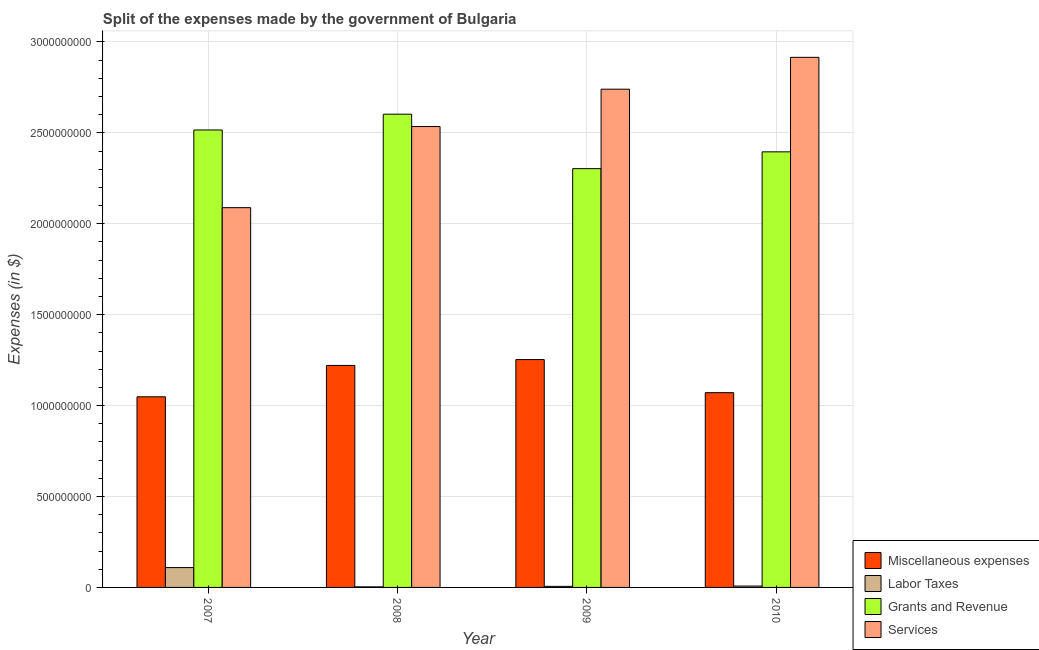How many different coloured bars are there?
Offer a very short reply. 4. How many groups of bars are there?
Ensure brevity in your answer.  4. How many bars are there on the 1st tick from the right?
Your response must be concise. 4. What is the amount spent on labor taxes in 2009?
Provide a succinct answer. 5.93e+06. Across all years, what is the maximum amount spent on services?
Keep it short and to the point. 2.92e+09. Across all years, what is the minimum amount spent on labor taxes?
Keep it short and to the point. 3.12e+06. In which year was the amount spent on labor taxes minimum?
Make the answer very short. 2008. What is the total amount spent on services in the graph?
Give a very brief answer. 1.03e+1. What is the difference between the amount spent on labor taxes in 2008 and that in 2009?
Keep it short and to the point. -2.81e+06. What is the difference between the amount spent on miscellaneous expenses in 2009 and the amount spent on services in 2007?
Your answer should be very brief. 2.05e+08. What is the average amount spent on grants and revenue per year?
Your answer should be compact. 2.45e+09. In the year 2008, what is the difference between the amount spent on services and amount spent on labor taxes?
Offer a terse response. 0. What is the ratio of the amount spent on miscellaneous expenses in 2007 to that in 2010?
Make the answer very short. 0.98. Is the amount spent on grants and revenue in 2008 less than that in 2009?
Offer a terse response. No. What is the difference between the highest and the second highest amount spent on miscellaneous expenses?
Give a very brief answer. 3.22e+07. What is the difference between the highest and the lowest amount spent on miscellaneous expenses?
Ensure brevity in your answer.  2.05e+08. In how many years, is the amount spent on services greater than the average amount spent on services taken over all years?
Your answer should be very brief. 2. Is the sum of the amount spent on labor taxes in 2007 and 2009 greater than the maximum amount spent on grants and revenue across all years?
Give a very brief answer. Yes. What does the 4th bar from the left in 2007 represents?
Your answer should be very brief. Services. What does the 2nd bar from the right in 2010 represents?
Offer a very short reply. Grants and Revenue. Is it the case that in every year, the sum of the amount spent on miscellaneous expenses and amount spent on labor taxes is greater than the amount spent on grants and revenue?
Ensure brevity in your answer.  No. How many bars are there?
Keep it short and to the point. 16. What is the difference between two consecutive major ticks on the Y-axis?
Ensure brevity in your answer.  5.00e+08. Are the values on the major ticks of Y-axis written in scientific E-notation?
Ensure brevity in your answer.  No. Does the graph contain grids?
Provide a short and direct response. Yes. What is the title of the graph?
Provide a short and direct response. Split of the expenses made by the government of Bulgaria. What is the label or title of the Y-axis?
Offer a very short reply. Expenses (in $). What is the Expenses (in $) in Miscellaneous expenses in 2007?
Make the answer very short. 1.05e+09. What is the Expenses (in $) of Labor Taxes in 2007?
Offer a terse response. 1.09e+08. What is the Expenses (in $) of Grants and Revenue in 2007?
Give a very brief answer. 2.52e+09. What is the Expenses (in $) of Services in 2007?
Your answer should be very brief. 2.09e+09. What is the Expenses (in $) of Miscellaneous expenses in 2008?
Provide a short and direct response. 1.22e+09. What is the Expenses (in $) of Labor Taxes in 2008?
Ensure brevity in your answer.  3.12e+06. What is the Expenses (in $) of Grants and Revenue in 2008?
Give a very brief answer. 2.60e+09. What is the Expenses (in $) of Services in 2008?
Give a very brief answer. 2.53e+09. What is the Expenses (in $) of Miscellaneous expenses in 2009?
Offer a very short reply. 1.25e+09. What is the Expenses (in $) in Labor Taxes in 2009?
Offer a terse response. 5.93e+06. What is the Expenses (in $) in Grants and Revenue in 2009?
Give a very brief answer. 2.30e+09. What is the Expenses (in $) in Services in 2009?
Provide a succinct answer. 2.74e+09. What is the Expenses (in $) of Miscellaneous expenses in 2010?
Give a very brief answer. 1.07e+09. What is the Expenses (in $) of Labor Taxes in 2010?
Give a very brief answer. 7.65e+06. What is the Expenses (in $) of Grants and Revenue in 2010?
Ensure brevity in your answer.  2.40e+09. What is the Expenses (in $) of Services in 2010?
Offer a very short reply. 2.92e+09. Across all years, what is the maximum Expenses (in $) of Miscellaneous expenses?
Provide a short and direct response. 1.25e+09. Across all years, what is the maximum Expenses (in $) of Labor Taxes?
Offer a terse response. 1.09e+08. Across all years, what is the maximum Expenses (in $) in Grants and Revenue?
Your answer should be very brief. 2.60e+09. Across all years, what is the maximum Expenses (in $) of Services?
Ensure brevity in your answer.  2.92e+09. Across all years, what is the minimum Expenses (in $) in Miscellaneous expenses?
Ensure brevity in your answer.  1.05e+09. Across all years, what is the minimum Expenses (in $) in Labor Taxes?
Your answer should be very brief. 3.12e+06. Across all years, what is the minimum Expenses (in $) in Grants and Revenue?
Your response must be concise. 2.30e+09. Across all years, what is the minimum Expenses (in $) in Services?
Offer a terse response. 2.09e+09. What is the total Expenses (in $) in Miscellaneous expenses in the graph?
Provide a short and direct response. 4.59e+09. What is the total Expenses (in $) of Labor Taxes in the graph?
Provide a succinct answer. 1.26e+08. What is the total Expenses (in $) of Grants and Revenue in the graph?
Your answer should be compact. 9.82e+09. What is the total Expenses (in $) of Services in the graph?
Your answer should be compact. 1.03e+1. What is the difference between the Expenses (in $) of Miscellaneous expenses in 2007 and that in 2008?
Your response must be concise. -1.72e+08. What is the difference between the Expenses (in $) in Labor Taxes in 2007 and that in 2008?
Provide a short and direct response. 1.06e+08. What is the difference between the Expenses (in $) of Grants and Revenue in 2007 and that in 2008?
Give a very brief answer. -8.67e+07. What is the difference between the Expenses (in $) of Services in 2007 and that in 2008?
Offer a terse response. -4.46e+08. What is the difference between the Expenses (in $) in Miscellaneous expenses in 2007 and that in 2009?
Provide a succinct answer. -2.05e+08. What is the difference between the Expenses (in $) in Labor Taxes in 2007 and that in 2009?
Provide a short and direct response. 1.03e+08. What is the difference between the Expenses (in $) of Grants and Revenue in 2007 and that in 2009?
Give a very brief answer. 2.13e+08. What is the difference between the Expenses (in $) of Services in 2007 and that in 2009?
Your answer should be very brief. -6.52e+08. What is the difference between the Expenses (in $) in Miscellaneous expenses in 2007 and that in 2010?
Provide a succinct answer. -2.27e+07. What is the difference between the Expenses (in $) in Labor Taxes in 2007 and that in 2010?
Provide a succinct answer. 1.01e+08. What is the difference between the Expenses (in $) of Grants and Revenue in 2007 and that in 2010?
Make the answer very short. 1.20e+08. What is the difference between the Expenses (in $) of Services in 2007 and that in 2010?
Make the answer very short. -8.27e+08. What is the difference between the Expenses (in $) in Miscellaneous expenses in 2008 and that in 2009?
Your answer should be very brief. -3.22e+07. What is the difference between the Expenses (in $) of Labor Taxes in 2008 and that in 2009?
Ensure brevity in your answer.  -2.81e+06. What is the difference between the Expenses (in $) of Grants and Revenue in 2008 and that in 2009?
Provide a succinct answer. 2.99e+08. What is the difference between the Expenses (in $) in Services in 2008 and that in 2009?
Provide a short and direct response. -2.05e+08. What is the difference between the Expenses (in $) in Miscellaneous expenses in 2008 and that in 2010?
Ensure brevity in your answer.  1.50e+08. What is the difference between the Expenses (in $) in Labor Taxes in 2008 and that in 2010?
Your answer should be compact. -4.53e+06. What is the difference between the Expenses (in $) of Grants and Revenue in 2008 and that in 2010?
Make the answer very short. 2.07e+08. What is the difference between the Expenses (in $) of Services in 2008 and that in 2010?
Offer a terse response. -3.81e+08. What is the difference between the Expenses (in $) of Miscellaneous expenses in 2009 and that in 2010?
Your answer should be compact. 1.82e+08. What is the difference between the Expenses (in $) in Labor Taxes in 2009 and that in 2010?
Your answer should be very brief. -1.72e+06. What is the difference between the Expenses (in $) of Grants and Revenue in 2009 and that in 2010?
Your answer should be very brief. -9.24e+07. What is the difference between the Expenses (in $) of Services in 2009 and that in 2010?
Your answer should be compact. -1.75e+08. What is the difference between the Expenses (in $) of Miscellaneous expenses in 2007 and the Expenses (in $) of Labor Taxes in 2008?
Offer a very short reply. 1.05e+09. What is the difference between the Expenses (in $) in Miscellaneous expenses in 2007 and the Expenses (in $) in Grants and Revenue in 2008?
Provide a short and direct response. -1.55e+09. What is the difference between the Expenses (in $) of Miscellaneous expenses in 2007 and the Expenses (in $) of Services in 2008?
Make the answer very short. -1.49e+09. What is the difference between the Expenses (in $) in Labor Taxes in 2007 and the Expenses (in $) in Grants and Revenue in 2008?
Your answer should be very brief. -2.49e+09. What is the difference between the Expenses (in $) in Labor Taxes in 2007 and the Expenses (in $) in Services in 2008?
Offer a terse response. -2.43e+09. What is the difference between the Expenses (in $) of Grants and Revenue in 2007 and the Expenses (in $) of Services in 2008?
Keep it short and to the point. -1.88e+07. What is the difference between the Expenses (in $) of Miscellaneous expenses in 2007 and the Expenses (in $) of Labor Taxes in 2009?
Provide a short and direct response. 1.04e+09. What is the difference between the Expenses (in $) in Miscellaneous expenses in 2007 and the Expenses (in $) in Grants and Revenue in 2009?
Give a very brief answer. -1.25e+09. What is the difference between the Expenses (in $) of Miscellaneous expenses in 2007 and the Expenses (in $) of Services in 2009?
Make the answer very short. -1.69e+09. What is the difference between the Expenses (in $) of Labor Taxes in 2007 and the Expenses (in $) of Grants and Revenue in 2009?
Offer a very short reply. -2.19e+09. What is the difference between the Expenses (in $) in Labor Taxes in 2007 and the Expenses (in $) in Services in 2009?
Offer a terse response. -2.63e+09. What is the difference between the Expenses (in $) of Grants and Revenue in 2007 and the Expenses (in $) of Services in 2009?
Make the answer very short. -2.24e+08. What is the difference between the Expenses (in $) in Miscellaneous expenses in 2007 and the Expenses (in $) in Labor Taxes in 2010?
Provide a succinct answer. 1.04e+09. What is the difference between the Expenses (in $) of Miscellaneous expenses in 2007 and the Expenses (in $) of Grants and Revenue in 2010?
Your answer should be very brief. -1.35e+09. What is the difference between the Expenses (in $) of Miscellaneous expenses in 2007 and the Expenses (in $) of Services in 2010?
Your response must be concise. -1.87e+09. What is the difference between the Expenses (in $) of Labor Taxes in 2007 and the Expenses (in $) of Grants and Revenue in 2010?
Make the answer very short. -2.29e+09. What is the difference between the Expenses (in $) of Labor Taxes in 2007 and the Expenses (in $) of Services in 2010?
Your response must be concise. -2.81e+09. What is the difference between the Expenses (in $) of Grants and Revenue in 2007 and the Expenses (in $) of Services in 2010?
Keep it short and to the point. -3.99e+08. What is the difference between the Expenses (in $) of Miscellaneous expenses in 2008 and the Expenses (in $) of Labor Taxes in 2009?
Provide a succinct answer. 1.21e+09. What is the difference between the Expenses (in $) in Miscellaneous expenses in 2008 and the Expenses (in $) in Grants and Revenue in 2009?
Make the answer very short. -1.08e+09. What is the difference between the Expenses (in $) in Miscellaneous expenses in 2008 and the Expenses (in $) in Services in 2009?
Ensure brevity in your answer.  -1.52e+09. What is the difference between the Expenses (in $) in Labor Taxes in 2008 and the Expenses (in $) in Grants and Revenue in 2009?
Provide a succinct answer. -2.30e+09. What is the difference between the Expenses (in $) in Labor Taxes in 2008 and the Expenses (in $) in Services in 2009?
Give a very brief answer. -2.74e+09. What is the difference between the Expenses (in $) in Grants and Revenue in 2008 and the Expenses (in $) in Services in 2009?
Offer a terse response. -1.37e+08. What is the difference between the Expenses (in $) in Miscellaneous expenses in 2008 and the Expenses (in $) in Labor Taxes in 2010?
Offer a terse response. 1.21e+09. What is the difference between the Expenses (in $) in Miscellaneous expenses in 2008 and the Expenses (in $) in Grants and Revenue in 2010?
Offer a very short reply. -1.17e+09. What is the difference between the Expenses (in $) in Miscellaneous expenses in 2008 and the Expenses (in $) in Services in 2010?
Ensure brevity in your answer.  -1.69e+09. What is the difference between the Expenses (in $) in Labor Taxes in 2008 and the Expenses (in $) in Grants and Revenue in 2010?
Offer a very short reply. -2.39e+09. What is the difference between the Expenses (in $) of Labor Taxes in 2008 and the Expenses (in $) of Services in 2010?
Ensure brevity in your answer.  -2.91e+09. What is the difference between the Expenses (in $) in Grants and Revenue in 2008 and the Expenses (in $) in Services in 2010?
Your answer should be compact. -3.13e+08. What is the difference between the Expenses (in $) of Miscellaneous expenses in 2009 and the Expenses (in $) of Labor Taxes in 2010?
Your response must be concise. 1.25e+09. What is the difference between the Expenses (in $) of Miscellaneous expenses in 2009 and the Expenses (in $) of Grants and Revenue in 2010?
Provide a short and direct response. -1.14e+09. What is the difference between the Expenses (in $) in Miscellaneous expenses in 2009 and the Expenses (in $) in Services in 2010?
Offer a very short reply. -1.66e+09. What is the difference between the Expenses (in $) of Labor Taxes in 2009 and the Expenses (in $) of Grants and Revenue in 2010?
Make the answer very short. -2.39e+09. What is the difference between the Expenses (in $) in Labor Taxes in 2009 and the Expenses (in $) in Services in 2010?
Your answer should be very brief. -2.91e+09. What is the difference between the Expenses (in $) of Grants and Revenue in 2009 and the Expenses (in $) of Services in 2010?
Give a very brief answer. -6.12e+08. What is the average Expenses (in $) in Miscellaneous expenses per year?
Ensure brevity in your answer.  1.15e+09. What is the average Expenses (in $) in Labor Taxes per year?
Give a very brief answer. 3.14e+07. What is the average Expenses (in $) of Grants and Revenue per year?
Provide a succinct answer. 2.45e+09. What is the average Expenses (in $) in Services per year?
Ensure brevity in your answer.  2.57e+09. In the year 2007, what is the difference between the Expenses (in $) in Miscellaneous expenses and Expenses (in $) in Labor Taxes?
Offer a very short reply. 9.39e+08. In the year 2007, what is the difference between the Expenses (in $) in Miscellaneous expenses and Expenses (in $) in Grants and Revenue?
Your answer should be very brief. -1.47e+09. In the year 2007, what is the difference between the Expenses (in $) of Miscellaneous expenses and Expenses (in $) of Services?
Offer a terse response. -1.04e+09. In the year 2007, what is the difference between the Expenses (in $) of Labor Taxes and Expenses (in $) of Grants and Revenue?
Give a very brief answer. -2.41e+09. In the year 2007, what is the difference between the Expenses (in $) in Labor Taxes and Expenses (in $) in Services?
Your answer should be compact. -1.98e+09. In the year 2007, what is the difference between the Expenses (in $) in Grants and Revenue and Expenses (in $) in Services?
Provide a succinct answer. 4.27e+08. In the year 2008, what is the difference between the Expenses (in $) of Miscellaneous expenses and Expenses (in $) of Labor Taxes?
Make the answer very short. 1.22e+09. In the year 2008, what is the difference between the Expenses (in $) of Miscellaneous expenses and Expenses (in $) of Grants and Revenue?
Your response must be concise. -1.38e+09. In the year 2008, what is the difference between the Expenses (in $) in Miscellaneous expenses and Expenses (in $) in Services?
Your answer should be compact. -1.31e+09. In the year 2008, what is the difference between the Expenses (in $) in Labor Taxes and Expenses (in $) in Grants and Revenue?
Your response must be concise. -2.60e+09. In the year 2008, what is the difference between the Expenses (in $) of Labor Taxes and Expenses (in $) of Services?
Ensure brevity in your answer.  -2.53e+09. In the year 2008, what is the difference between the Expenses (in $) of Grants and Revenue and Expenses (in $) of Services?
Your answer should be very brief. 6.79e+07. In the year 2009, what is the difference between the Expenses (in $) of Miscellaneous expenses and Expenses (in $) of Labor Taxes?
Your response must be concise. 1.25e+09. In the year 2009, what is the difference between the Expenses (in $) of Miscellaneous expenses and Expenses (in $) of Grants and Revenue?
Your response must be concise. -1.05e+09. In the year 2009, what is the difference between the Expenses (in $) of Miscellaneous expenses and Expenses (in $) of Services?
Your answer should be very brief. -1.49e+09. In the year 2009, what is the difference between the Expenses (in $) in Labor Taxes and Expenses (in $) in Grants and Revenue?
Make the answer very short. -2.30e+09. In the year 2009, what is the difference between the Expenses (in $) of Labor Taxes and Expenses (in $) of Services?
Ensure brevity in your answer.  -2.73e+09. In the year 2009, what is the difference between the Expenses (in $) of Grants and Revenue and Expenses (in $) of Services?
Give a very brief answer. -4.37e+08. In the year 2010, what is the difference between the Expenses (in $) of Miscellaneous expenses and Expenses (in $) of Labor Taxes?
Ensure brevity in your answer.  1.06e+09. In the year 2010, what is the difference between the Expenses (in $) in Miscellaneous expenses and Expenses (in $) in Grants and Revenue?
Ensure brevity in your answer.  -1.32e+09. In the year 2010, what is the difference between the Expenses (in $) in Miscellaneous expenses and Expenses (in $) in Services?
Ensure brevity in your answer.  -1.84e+09. In the year 2010, what is the difference between the Expenses (in $) of Labor Taxes and Expenses (in $) of Grants and Revenue?
Offer a very short reply. -2.39e+09. In the year 2010, what is the difference between the Expenses (in $) of Labor Taxes and Expenses (in $) of Services?
Offer a terse response. -2.91e+09. In the year 2010, what is the difference between the Expenses (in $) of Grants and Revenue and Expenses (in $) of Services?
Give a very brief answer. -5.20e+08. What is the ratio of the Expenses (in $) of Miscellaneous expenses in 2007 to that in 2008?
Provide a succinct answer. 0.86. What is the ratio of the Expenses (in $) in Labor Taxes in 2007 to that in 2008?
Keep it short and to the point. 34.94. What is the ratio of the Expenses (in $) in Grants and Revenue in 2007 to that in 2008?
Make the answer very short. 0.97. What is the ratio of the Expenses (in $) in Services in 2007 to that in 2008?
Give a very brief answer. 0.82. What is the ratio of the Expenses (in $) of Miscellaneous expenses in 2007 to that in 2009?
Provide a succinct answer. 0.84. What is the ratio of the Expenses (in $) of Labor Taxes in 2007 to that in 2009?
Keep it short and to the point. 18.4. What is the ratio of the Expenses (in $) of Grants and Revenue in 2007 to that in 2009?
Provide a short and direct response. 1.09. What is the ratio of the Expenses (in $) of Services in 2007 to that in 2009?
Provide a succinct answer. 0.76. What is the ratio of the Expenses (in $) in Miscellaneous expenses in 2007 to that in 2010?
Give a very brief answer. 0.98. What is the ratio of the Expenses (in $) of Labor Taxes in 2007 to that in 2010?
Offer a terse response. 14.26. What is the ratio of the Expenses (in $) of Grants and Revenue in 2007 to that in 2010?
Make the answer very short. 1.05. What is the ratio of the Expenses (in $) of Services in 2007 to that in 2010?
Your answer should be compact. 0.72. What is the ratio of the Expenses (in $) in Miscellaneous expenses in 2008 to that in 2009?
Your answer should be very brief. 0.97. What is the ratio of the Expenses (in $) of Labor Taxes in 2008 to that in 2009?
Your response must be concise. 0.53. What is the ratio of the Expenses (in $) in Grants and Revenue in 2008 to that in 2009?
Provide a succinct answer. 1.13. What is the ratio of the Expenses (in $) of Services in 2008 to that in 2009?
Your response must be concise. 0.93. What is the ratio of the Expenses (in $) of Miscellaneous expenses in 2008 to that in 2010?
Keep it short and to the point. 1.14. What is the ratio of the Expenses (in $) in Labor Taxes in 2008 to that in 2010?
Ensure brevity in your answer.  0.41. What is the ratio of the Expenses (in $) of Grants and Revenue in 2008 to that in 2010?
Give a very brief answer. 1.09. What is the ratio of the Expenses (in $) of Services in 2008 to that in 2010?
Offer a terse response. 0.87. What is the ratio of the Expenses (in $) in Miscellaneous expenses in 2009 to that in 2010?
Offer a terse response. 1.17. What is the ratio of the Expenses (in $) in Labor Taxes in 2009 to that in 2010?
Ensure brevity in your answer.  0.77. What is the ratio of the Expenses (in $) of Grants and Revenue in 2009 to that in 2010?
Keep it short and to the point. 0.96. What is the ratio of the Expenses (in $) in Services in 2009 to that in 2010?
Your response must be concise. 0.94. What is the difference between the highest and the second highest Expenses (in $) in Miscellaneous expenses?
Offer a terse response. 3.22e+07. What is the difference between the highest and the second highest Expenses (in $) in Labor Taxes?
Your answer should be compact. 1.01e+08. What is the difference between the highest and the second highest Expenses (in $) in Grants and Revenue?
Offer a terse response. 8.67e+07. What is the difference between the highest and the second highest Expenses (in $) of Services?
Offer a very short reply. 1.75e+08. What is the difference between the highest and the lowest Expenses (in $) in Miscellaneous expenses?
Give a very brief answer. 2.05e+08. What is the difference between the highest and the lowest Expenses (in $) of Labor Taxes?
Provide a short and direct response. 1.06e+08. What is the difference between the highest and the lowest Expenses (in $) in Grants and Revenue?
Give a very brief answer. 2.99e+08. What is the difference between the highest and the lowest Expenses (in $) of Services?
Provide a short and direct response. 8.27e+08. 